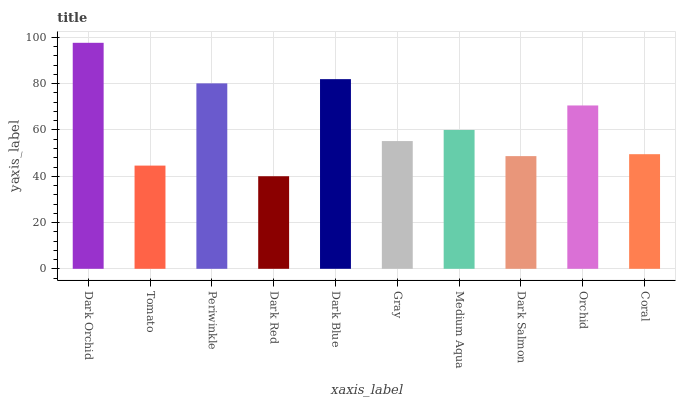Is Dark Red the minimum?
Answer yes or no. Yes. Is Dark Orchid the maximum?
Answer yes or no. Yes. Is Tomato the minimum?
Answer yes or no. No. Is Tomato the maximum?
Answer yes or no. No. Is Dark Orchid greater than Tomato?
Answer yes or no. Yes. Is Tomato less than Dark Orchid?
Answer yes or no. Yes. Is Tomato greater than Dark Orchid?
Answer yes or no. No. Is Dark Orchid less than Tomato?
Answer yes or no. No. Is Medium Aqua the high median?
Answer yes or no. Yes. Is Gray the low median?
Answer yes or no. Yes. Is Dark Salmon the high median?
Answer yes or no. No. Is Tomato the low median?
Answer yes or no. No. 